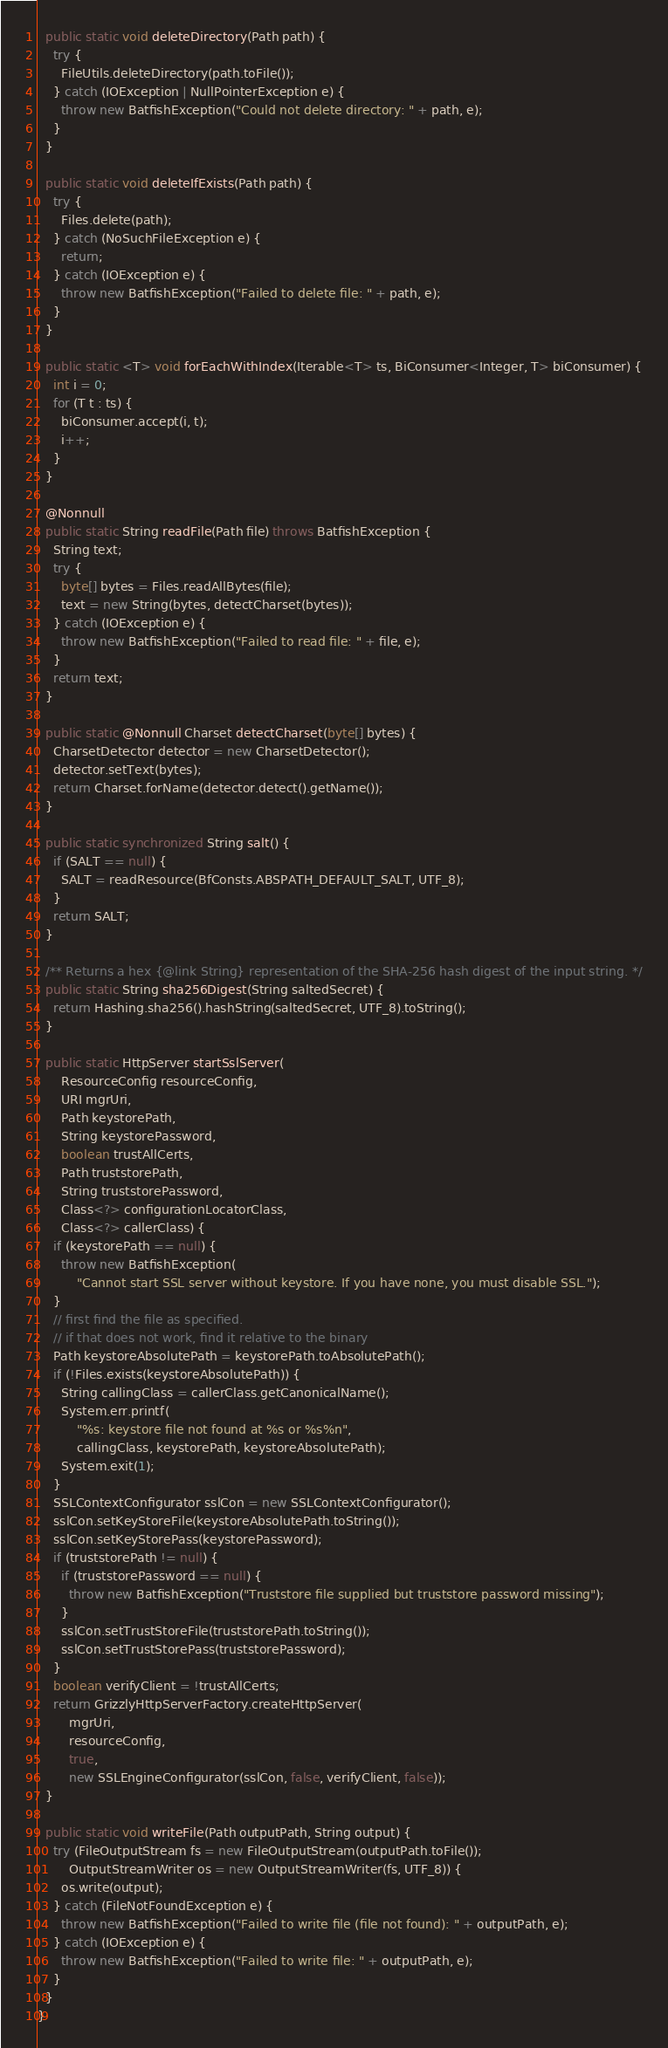Convert code to text. <code><loc_0><loc_0><loc_500><loc_500><_Java_>
  public static void deleteDirectory(Path path) {
    try {
      FileUtils.deleteDirectory(path.toFile());
    } catch (IOException | NullPointerException e) {
      throw new BatfishException("Could not delete directory: " + path, e);
    }
  }

  public static void deleteIfExists(Path path) {
    try {
      Files.delete(path);
    } catch (NoSuchFileException e) {
      return;
    } catch (IOException e) {
      throw new BatfishException("Failed to delete file: " + path, e);
    }
  }

  public static <T> void forEachWithIndex(Iterable<T> ts, BiConsumer<Integer, T> biConsumer) {
    int i = 0;
    for (T t : ts) {
      biConsumer.accept(i, t);
      i++;
    }
  }

  @Nonnull
  public static String readFile(Path file) throws BatfishException {
    String text;
    try {
      byte[] bytes = Files.readAllBytes(file);
      text = new String(bytes, detectCharset(bytes));
    } catch (IOException e) {
      throw new BatfishException("Failed to read file: " + file, e);
    }
    return text;
  }

  public static @Nonnull Charset detectCharset(byte[] bytes) {
    CharsetDetector detector = new CharsetDetector();
    detector.setText(bytes);
    return Charset.forName(detector.detect().getName());
  }

  public static synchronized String salt() {
    if (SALT == null) {
      SALT = readResource(BfConsts.ABSPATH_DEFAULT_SALT, UTF_8);
    }
    return SALT;
  }

  /** Returns a hex {@link String} representation of the SHA-256 hash digest of the input string. */
  public static String sha256Digest(String saltedSecret) {
    return Hashing.sha256().hashString(saltedSecret, UTF_8).toString();
  }

  public static HttpServer startSslServer(
      ResourceConfig resourceConfig,
      URI mgrUri,
      Path keystorePath,
      String keystorePassword,
      boolean trustAllCerts,
      Path truststorePath,
      String truststorePassword,
      Class<?> configurationLocatorClass,
      Class<?> callerClass) {
    if (keystorePath == null) {
      throw new BatfishException(
          "Cannot start SSL server without keystore. If you have none, you must disable SSL.");
    }
    // first find the file as specified.
    // if that does not work, find it relative to the binary
    Path keystoreAbsolutePath = keystorePath.toAbsolutePath();
    if (!Files.exists(keystoreAbsolutePath)) {
      String callingClass = callerClass.getCanonicalName();
      System.err.printf(
          "%s: keystore file not found at %s or %s%n",
          callingClass, keystorePath, keystoreAbsolutePath);
      System.exit(1);
    }
    SSLContextConfigurator sslCon = new SSLContextConfigurator();
    sslCon.setKeyStoreFile(keystoreAbsolutePath.toString());
    sslCon.setKeyStorePass(keystorePassword);
    if (truststorePath != null) {
      if (truststorePassword == null) {
        throw new BatfishException("Truststore file supplied but truststore password missing");
      }
      sslCon.setTrustStoreFile(truststorePath.toString());
      sslCon.setTrustStorePass(truststorePassword);
    }
    boolean verifyClient = !trustAllCerts;
    return GrizzlyHttpServerFactory.createHttpServer(
        mgrUri,
        resourceConfig,
        true,
        new SSLEngineConfigurator(sslCon, false, verifyClient, false));
  }

  public static void writeFile(Path outputPath, String output) {
    try (FileOutputStream fs = new FileOutputStream(outputPath.toFile());
        OutputStreamWriter os = new OutputStreamWriter(fs, UTF_8)) {
      os.write(output);
    } catch (FileNotFoundException e) {
      throw new BatfishException("Failed to write file (file not found): " + outputPath, e);
    } catch (IOException e) {
      throw new BatfishException("Failed to write file: " + outputPath, e);
    }
  }
}
</code> 